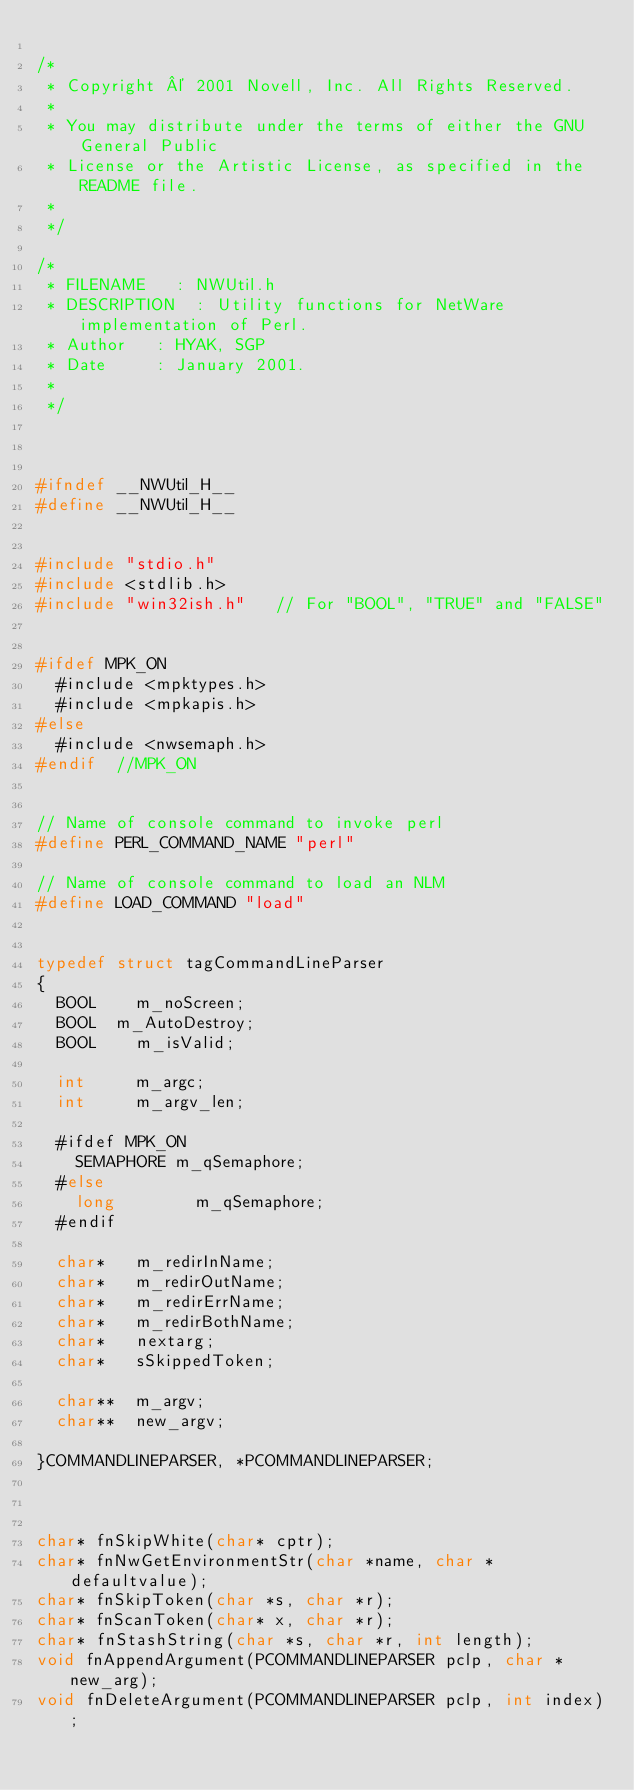Convert code to text. <code><loc_0><loc_0><loc_500><loc_500><_C_>
/*
 * Copyright © 2001 Novell, Inc. All Rights Reserved.
 *
 * You may distribute under the terms of either the GNU General Public
 * License or the Artistic License, as specified in the README file.
 *
 */

/*
 * FILENAME		:	NWUtil.h
 * DESCRIPTION	:	Utility functions for NetWare implementation of Perl.
 * Author		:	HYAK, SGP
 * Date			:	January 2001.
 *
 */



#ifndef __NWUtil_H__
#define __NWUtil_H__


#include "stdio.h"
#include <stdlib.h>
#include "win32ish.h"		// For "BOOL", "TRUE" and "FALSE"


#ifdef MPK_ON
	#include <mpktypes.h>	
	#include <mpkapis.h>
#else
	#include <nwsemaph.h>
#endif	//MPK_ON


// Name of console command to invoke perl
#define PERL_COMMAND_NAME "perl"

// Name of console command to load an NLM
#define LOAD_COMMAND "load"


typedef struct tagCommandLineParser
{
	BOOL    m_noScreen;
	BOOL	m_AutoDestroy;
	BOOL    m_isValid;

	int	    m_argc;
	int     m_argv_len;
	
	#ifdef MPK_ON
		SEMAPHORE	m_qSemaphore;
	#else
		long        m_qSemaphore;
	#endif

	char*   m_redirInName;
	char*   m_redirOutName;
	char*   m_redirErrName;
	char*   m_redirBothName;
	char*   nextarg;
	char*   sSkippedToken;

	char**  m_argv;
	char**  new_argv;

}COMMANDLINEPARSER, *PCOMMANDLINEPARSER;



char* fnSkipWhite(char* cptr);
char* fnNwGetEnvironmentStr(char *name, char *defaultvalue);
char* fnSkipToken(char *s, char *r);
char* fnScanToken(char* x, char *r);
char* fnStashString(char *s, char *r, int length);
void fnAppendArgument(PCOMMANDLINEPARSER pclp, char * new_arg);
void fnDeleteArgument(PCOMMANDLINEPARSER pclp, int index);</code> 